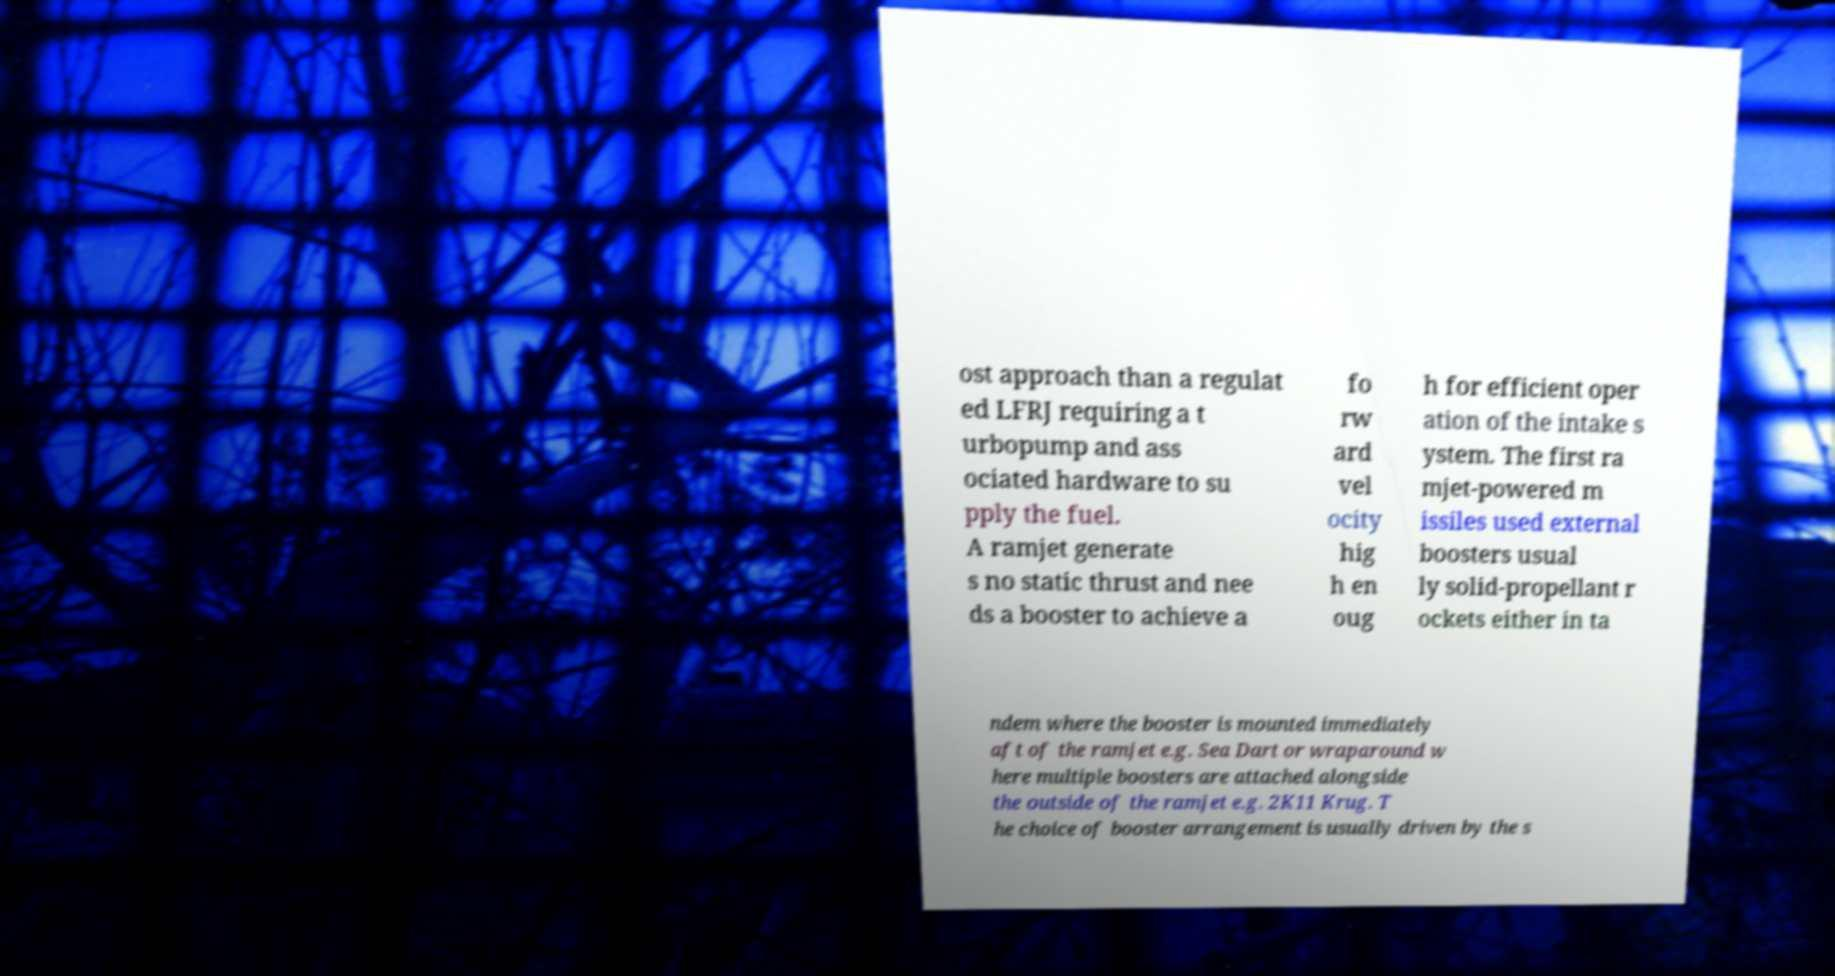What messages or text are displayed in this image? I need them in a readable, typed format. ost approach than a regulat ed LFRJ requiring a t urbopump and ass ociated hardware to su pply the fuel. A ramjet generate s no static thrust and nee ds a booster to achieve a fo rw ard vel ocity hig h en oug h for efficient oper ation of the intake s ystem. The first ra mjet-powered m issiles used external boosters usual ly solid-propellant r ockets either in ta ndem where the booster is mounted immediately aft of the ramjet e.g. Sea Dart or wraparound w here multiple boosters are attached alongside the outside of the ramjet e.g. 2K11 Krug. T he choice of booster arrangement is usually driven by the s 